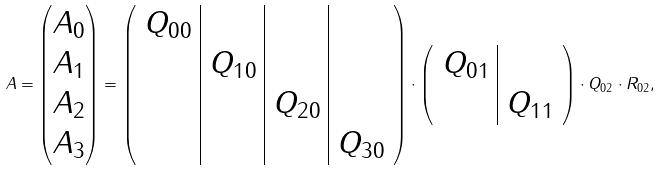<formula> <loc_0><loc_0><loc_500><loc_500>A = \begin{pmatrix} A _ { 0 } \\ A _ { 1 } \\ A _ { 2 } \\ A _ { 3 } \\ \end{pmatrix} = \left ( \begin{array} { c | c | c | c } Q _ { 0 0 } & & & \\ & Q _ { 1 0 } & & \\ & & Q _ { 2 0 } & \\ & & & Q _ { 3 0 } \\ \end{array} \right ) \cdot \left ( \begin{array} { c | c } Q _ { 0 1 } & \\ & Q _ { 1 1 } \\ \end{array} \right ) \cdot Q _ { 0 2 } \cdot R _ { 0 2 } ,</formula> 